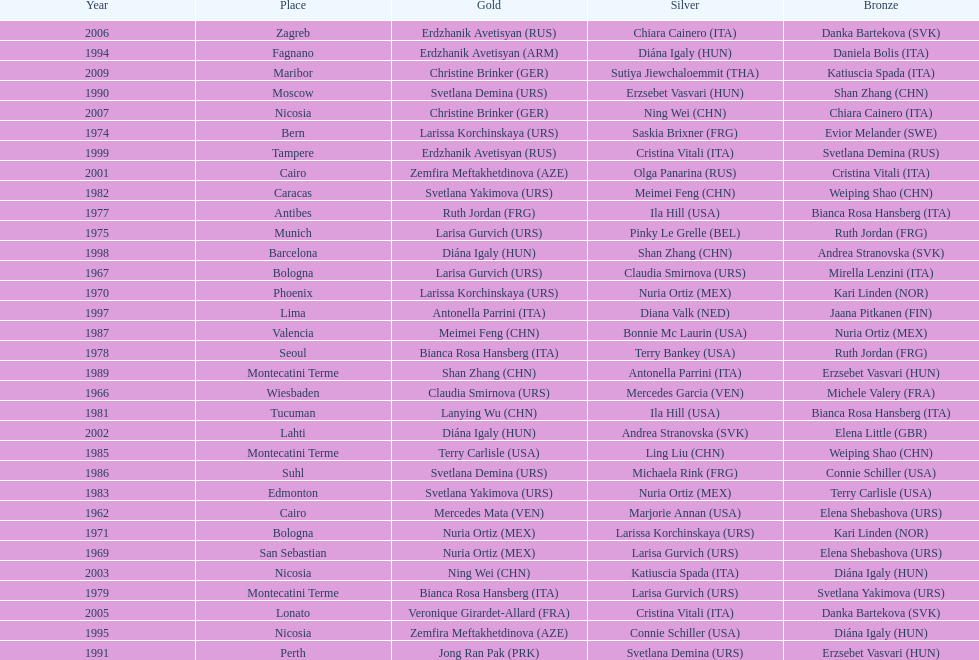Who won the only gold medal in 1962? Mercedes Mata. 